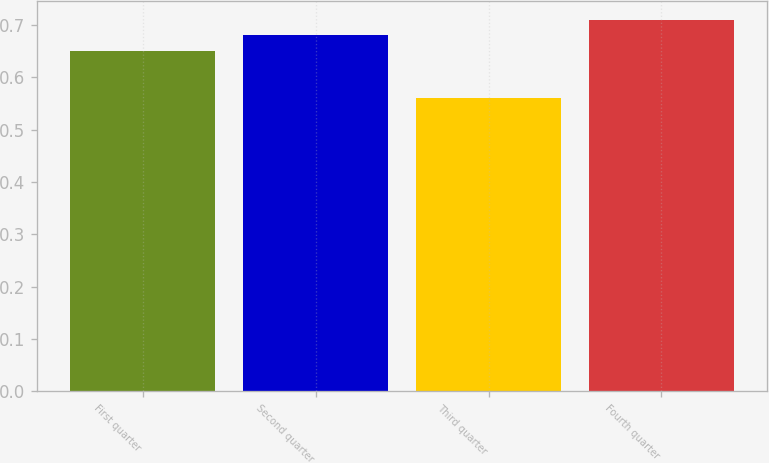Convert chart to OTSL. <chart><loc_0><loc_0><loc_500><loc_500><bar_chart><fcel>First quarter<fcel>Second quarter<fcel>Third quarter<fcel>Fourth quarter<nl><fcel>0.65<fcel>0.68<fcel>0.56<fcel>0.71<nl></chart> 